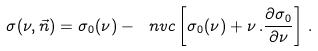<formula> <loc_0><loc_0><loc_500><loc_500>\sigma ( \nu , \vec { n } ) = \sigma _ { 0 } ( \nu ) - \ n v c \left [ \sigma _ { 0 } ( \nu ) + \nu \, . \frac { \partial \sigma _ { 0 } } { \partial \nu } \right ] \, .</formula> 